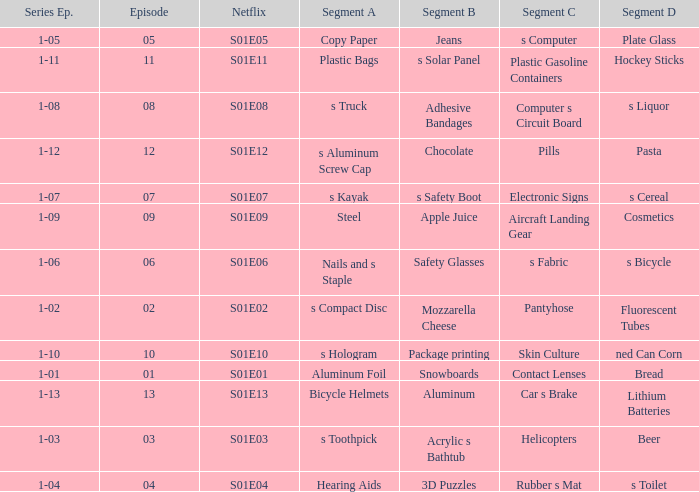What is the Netflix number having a segment of C of pills? S01E12. 